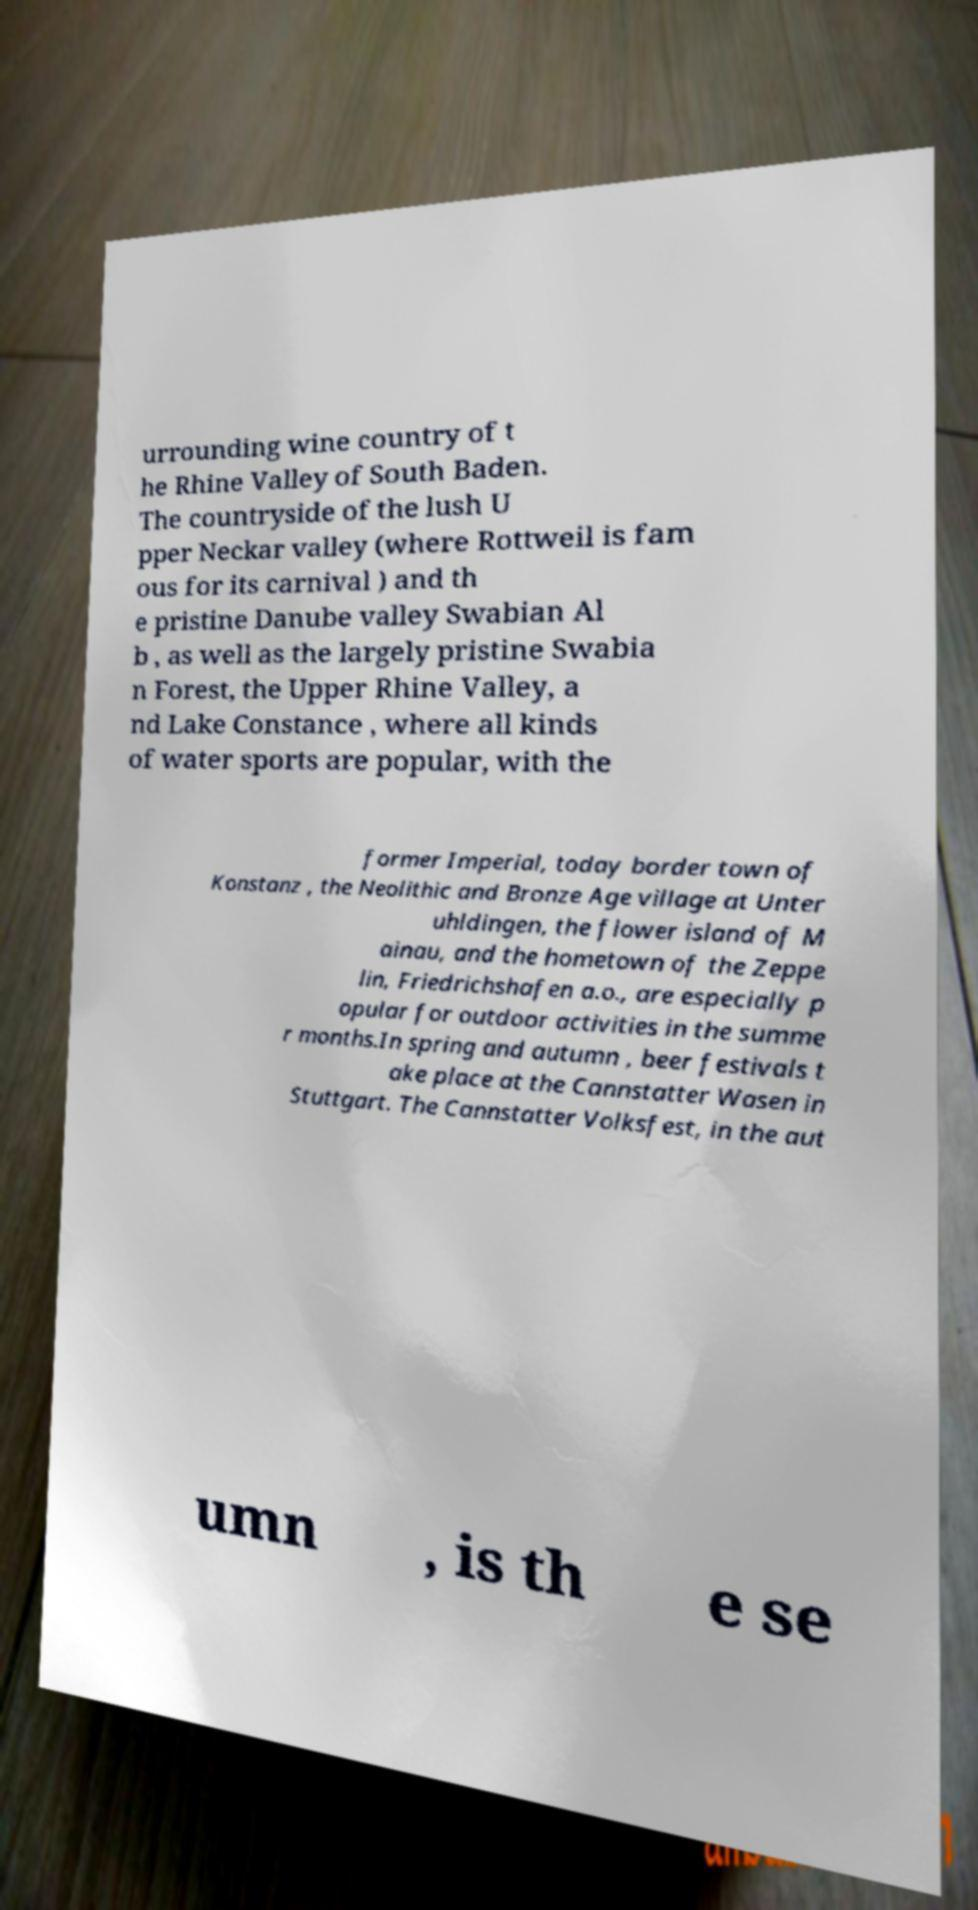Can you read and provide the text displayed in the image?This photo seems to have some interesting text. Can you extract and type it out for me? urrounding wine country of t he Rhine Valley of South Baden. The countryside of the lush U pper Neckar valley (where Rottweil is fam ous for its carnival ) and th e pristine Danube valley Swabian Al b , as well as the largely pristine Swabia n Forest, the Upper Rhine Valley, a nd Lake Constance , where all kinds of water sports are popular, with the former Imperial, today border town of Konstanz , the Neolithic and Bronze Age village at Unter uhldingen, the flower island of M ainau, and the hometown of the Zeppe lin, Friedrichshafen a.o., are especially p opular for outdoor activities in the summe r months.In spring and autumn , beer festivals t ake place at the Cannstatter Wasen in Stuttgart. The Cannstatter Volksfest, in the aut umn , is th e se 